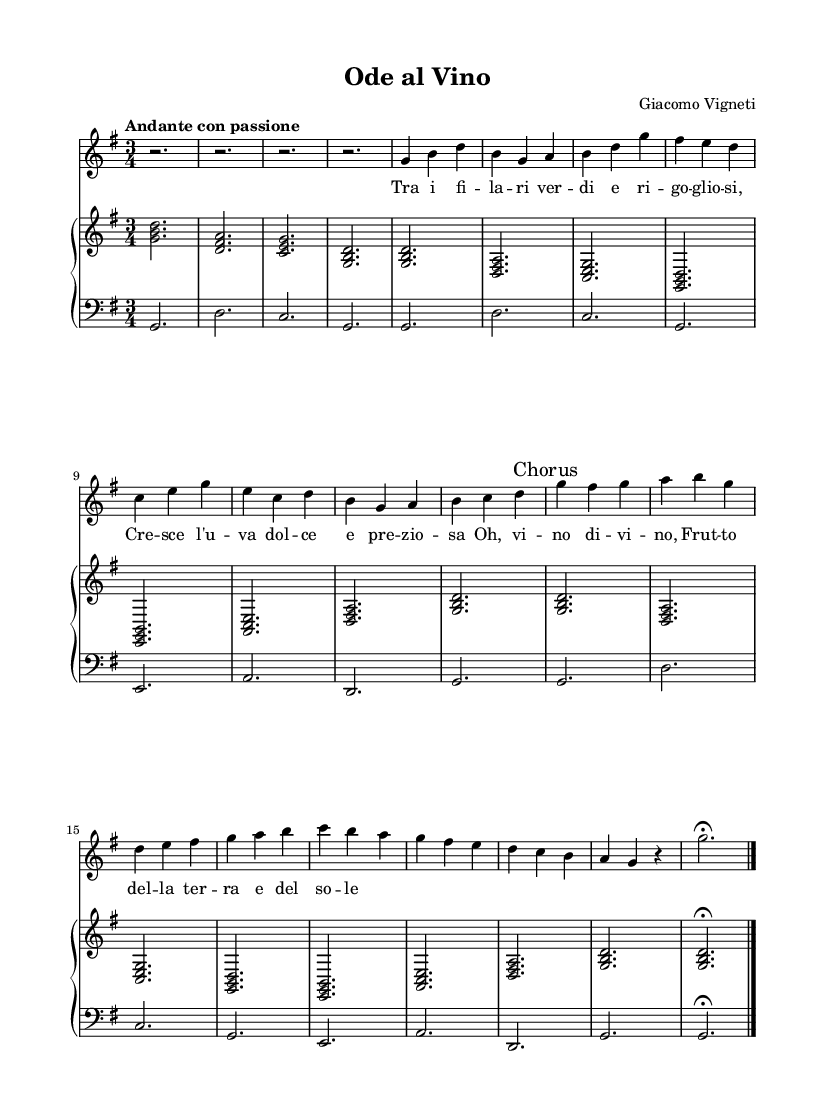What is the key signature of this music? The key signature is G major, which has one sharp (F#). This can be determined by looking at the key signature symbol placed at the beginning of the staff.
Answer: G major What is the time signature of this music? The time signature is 3/4, indicating there are three beats in each measure and that the quarter note gets one beat. This can be seen at the beginning of the score.
Answer: 3/4 What is the tempo marking given for this piece? The tempo marking is "Andante con passione," which suggests a moderately slow pace with passion. It is indicated in the score at the beginning, usually following the key signature and time signature.
Answer: Andante con passione How many measures are in the Chorus? There are 8 measures in the Chorus section. By counting the measures marked as "Chorus," we can identify the number of measures in that section.
Answer: 8 measures Which instrument plays the upper staff? The upper staff is played by the piano. It is common in a score to designate the upper staff as the piano part, particularly in a piano accompaniment setting, as shown in the score layout.
Answer: Piano What is the dynamic marking used for the soprano part? The dynamic marking for the soprano part is "dynamicUp," suggesting that the notes should be played with a certain emphasis or volume. This is typically indicated above the vocal line in the score.
Answer: DynamicUp What is the theme celebrated in this aria? The aria celebrates the joys of winemaking. This can be inferred from the lyrics and the overall theme of the music. The text speaks about wine and its sweet and precious nature, which ties back to winemaking.
Answer: Joys of winemaking 